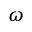<formula> <loc_0><loc_0><loc_500><loc_500>\omega</formula> 